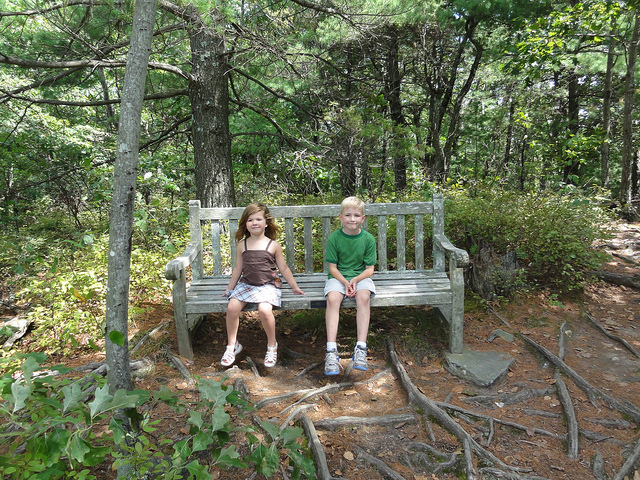Describe a possible scenario if it started raining. If it started raining while you were sitting on this bench, the forest would transform into a scene of tranquil beauty. Raindrops would patter gently on the leaves, creating a soothing, rhythmic sound. The air would become fresh and filled with the earthy scent of damp soil and pine. You might seek shelter under the dense canopy of the trees or enjoy the cooling rain as it lightly splashes on you. The wildlife would become more active, with birds singing and small animals scurrying for cover, adding a dynamic element to the peaceful setting. 